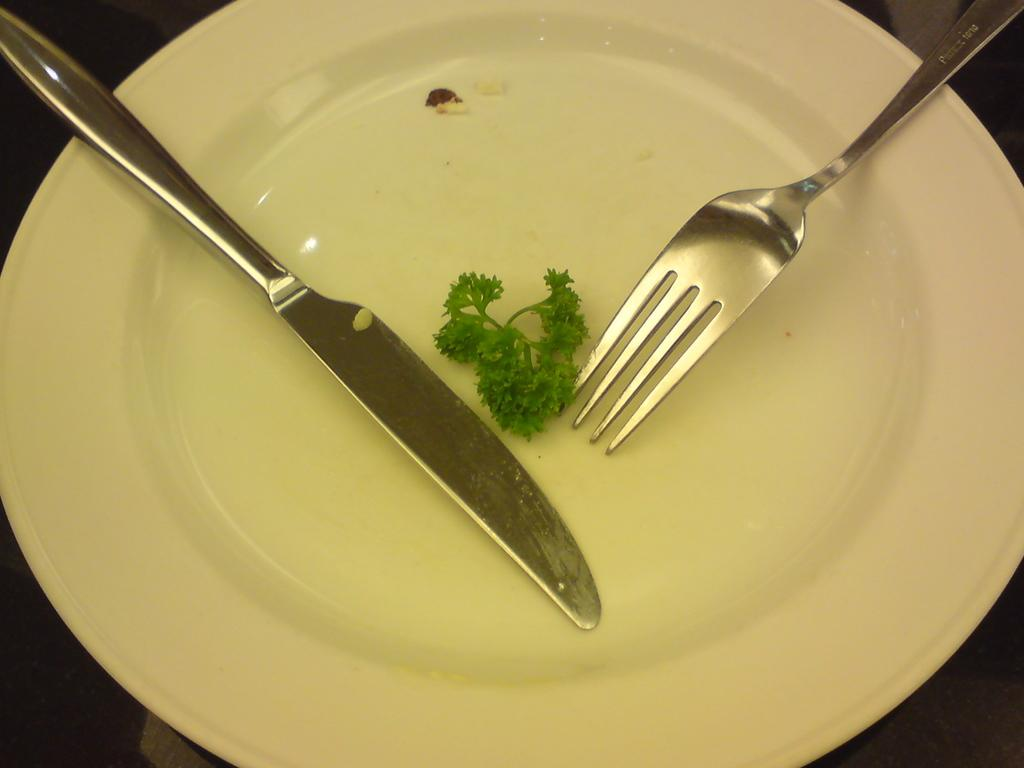What is located in the foreground of the image? There is a platter in the foreground of the image. What utensils are on the platter? There is a knife and a fork on the platter. What else is on the platter besides utensils? There are leaves on the platter. What is the color of the surface the platter is on? The platter is on a black surface. What type of building can be seen in the background of the image? There is no building visible in the image; it only shows a platter with utensils and leaves on a black surface. 